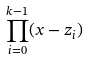Convert formula to latex. <formula><loc_0><loc_0><loc_500><loc_500>\prod _ { i = 0 } ^ { k - 1 } ( x - z _ { i } )</formula> 